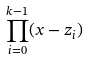Convert formula to latex. <formula><loc_0><loc_0><loc_500><loc_500>\prod _ { i = 0 } ^ { k - 1 } ( x - z _ { i } )</formula> 